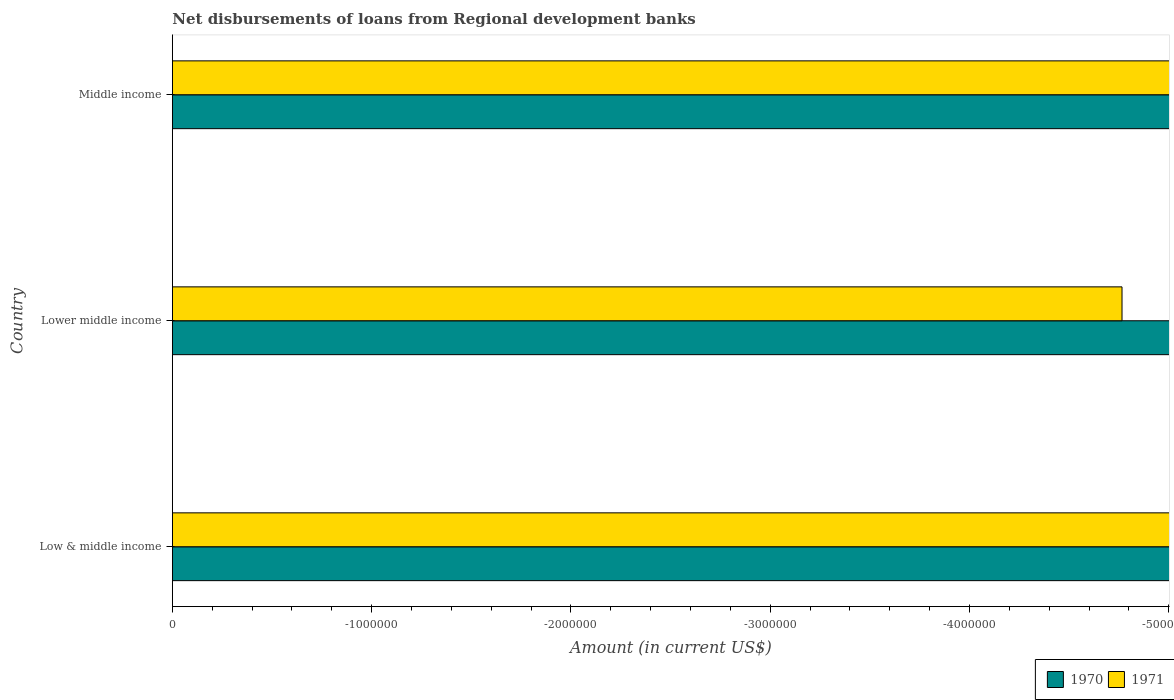Are the number of bars on each tick of the Y-axis equal?
Make the answer very short. Yes. How many bars are there on the 1st tick from the bottom?
Provide a short and direct response. 0. What is the label of the 2nd group of bars from the top?
Give a very brief answer. Lower middle income. Across all countries, what is the minimum amount of disbursements of loans from regional development banks in 1970?
Make the answer very short. 0. What is the total amount of disbursements of loans from regional development banks in 1970 in the graph?
Your answer should be compact. 0. What is the average amount of disbursements of loans from regional development banks in 1971 per country?
Offer a very short reply. 0. In how many countries, is the amount of disbursements of loans from regional development banks in 1971 greater than -2400000 US$?
Offer a terse response. 0. In how many countries, is the amount of disbursements of loans from regional development banks in 1970 greater than the average amount of disbursements of loans from regional development banks in 1970 taken over all countries?
Offer a terse response. 0. How many countries are there in the graph?
Give a very brief answer. 3. What is the difference between two consecutive major ticks on the X-axis?
Offer a very short reply. 1.00e+06. Where does the legend appear in the graph?
Give a very brief answer. Bottom right. How are the legend labels stacked?
Offer a very short reply. Horizontal. What is the title of the graph?
Offer a very short reply. Net disbursements of loans from Regional development banks. What is the label or title of the X-axis?
Offer a very short reply. Amount (in current US$). What is the average Amount (in current US$) of 1970 per country?
Make the answer very short. 0. 